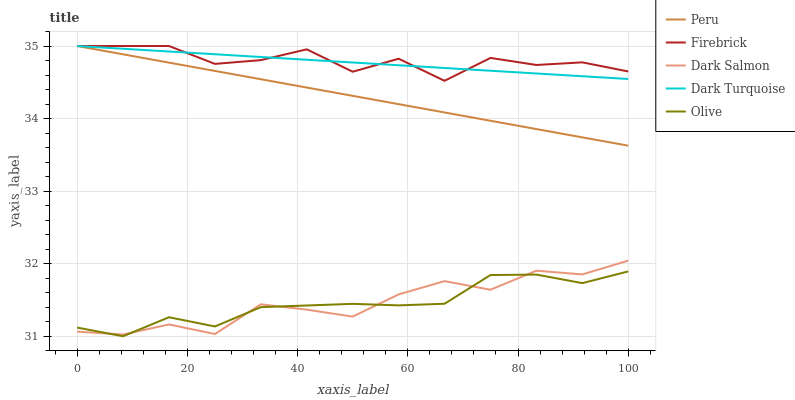Does Olive have the minimum area under the curve?
Answer yes or no. Yes. Does Firebrick have the maximum area under the curve?
Answer yes or no. Yes. Does Dark Turquoise have the minimum area under the curve?
Answer yes or no. No. Does Dark Turquoise have the maximum area under the curve?
Answer yes or no. No. Is Peru the smoothest?
Answer yes or no. Yes. Is Firebrick the roughest?
Answer yes or no. Yes. Is Dark Turquoise the smoothest?
Answer yes or no. No. Is Dark Turquoise the roughest?
Answer yes or no. No. Does Olive have the lowest value?
Answer yes or no. Yes. Does Firebrick have the lowest value?
Answer yes or no. No. Does Peru have the highest value?
Answer yes or no. Yes. Does Dark Salmon have the highest value?
Answer yes or no. No. Is Olive less than Firebrick?
Answer yes or no. Yes. Is Firebrick greater than Dark Salmon?
Answer yes or no. Yes. Does Dark Turquoise intersect Firebrick?
Answer yes or no. Yes. Is Dark Turquoise less than Firebrick?
Answer yes or no. No. Is Dark Turquoise greater than Firebrick?
Answer yes or no. No. Does Olive intersect Firebrick?
Answer yes or no. No. 